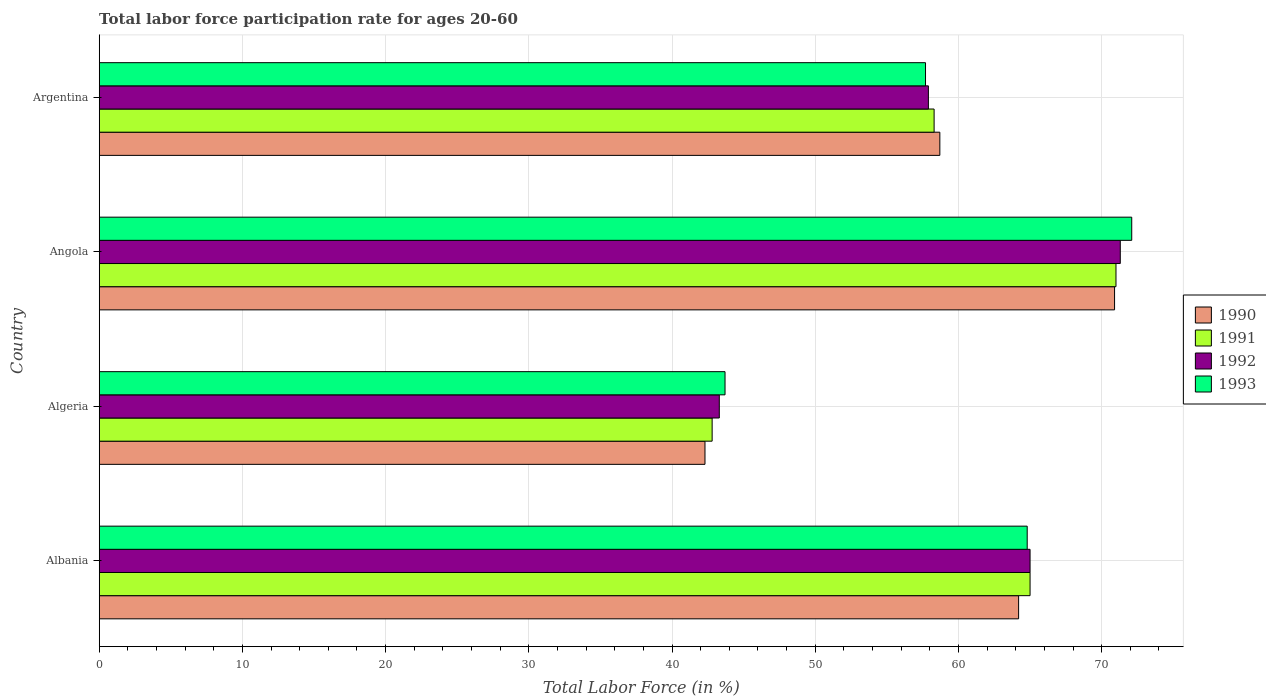How many different coloured bars are there?
Offer a very short reply. 4. How many groups of bars are there?
Keep it short and to the point. 4. How many bars are there on the 4th tick from the top?
Provide a short and direct response. 4. In how many cases, is the number of bars for a given country not equal to the number of legend labels?
Ensure brevity in your answer.  0. What is the labor force participation rate in 1992 in Albania?
Your answer should be very brief. 65. Across all countries, what is the maximum labor force participation rate in 1990?
Make the answer very short. 70.9. Across all countries, what is the minimum labor force participation rate in 1992?
Keep it short and to the point. 43.3. In which country was the labor force participation rate in 1993 maximum?
Offer a very short reply. Angola. In which country was the labor force participation rate in 1992 minimum?
Your response must be concise. Algeria. What is the total labor force participation rate in 1990 in the graph?
Ensure brevity in your answer.  236.1. What is the difference between the labor force participation rate in 1993 in Algeria and that in Angola?
Make the answer very short. -28.4. What is the difference between the labor force participation rate in 1990 in Argentina and the labor force participation rate in 1992 in Algeria?
Give a very brief answer. 15.4. What is the average labor force participation rate in 1991 per country?
Ensure brevity in your answer.  59.27. What is the difference between the labor force participation rate in 1991 and labor force participation rate in 1990 in Albania?
Offer a terse response. 0.8. What is the ratio of the labor force participation rate in 1993 in Algeria to that in Argentina?
Your answer should be compact. 0.76. Is the difference between the labor force participation rate in 1991 in Algeria and Argentina greater than the difference between the labor force participation rate in 1990 in Algeria and Argentina?
Your answer should be compact. Yes. What is the difference between the highest and the second highest labor force participation rate in 1991?
Provide a short and direct response. 6. What is the difference between the highest and the lowest labor force participation rate in 1990?
Keep it short and to the point. 28.6. What does the 3rd bar from the bottom in Algeria represents?
Provide a succinct answer. 1992. Is it the case that in every country, the sum of the labor force participation rate in 1993 and labor force participation rate in 1991 is greater than the labor force participation rate in 1992?
Offer a very short reply. Yes. How many bars are there?
Provide a short and direct response. 16. Are all the bars in the graph horizontal?
Offer a terse response. Yes. What is the difference between two consecutive major ticks on the X-axis?
Your response must be concise. 10. Are the values on the major ticks of X-axis written in scientific E-notation?
Your answer should be compact. No. Does the graph contain any zero values?
Provide a succinct answer. No. Does the graph contain grids?
Your response must be concise. Yes. Where does the legend appear in the graph?
Your answer should be compact. Center right. How many legend labels are there?
Provide a short and direct response. 4. How are the legend labels stacked?
Provide a succinct answer. Vertical. What is the title of the graph?
Give a very brief answer. Total labor force participation rate for ages 20-60. Does "2007" appear as one of the legend labels in the graph?
Provide a succinct answer. No. What is the label or title of the X-axis?
Keep it short and to the point. Total Labor Force (in %). What is the label or title of the Y-axis?
Ensure brevity in your answer.  Country. What is the Total Labor Force (in %) in 1990 in Albania?
Provide a short and direct response. 64.2. What is the Total Labor Force (in %) in 1993 in Albania?
Ensure brevity in your answer.  64.8. What is the Total Labor Force (in %) of 1990 in Algeria?
Offer a very short reply. 42.3. What is the Total Labor Force (in %) in 1991 in Algeria?
Make the answer very short. 42.8. What is the Total Labor Force (in %) in 1992 in Algeria?
Provide a short and direct response. 43.3. What is the Total Labor Force (in %) in 1993 in Algeria?
Your response must be concise. 43.7. What is the Total Labor Force (in %) in 1990 in Angola?
Make the answer very short. 70.9. What is the Total Labor Force (in %) of 1991 in Angola?
Keep it short and to the point. 71. What is the Total Labor Force (in %) in 1992 in Angola?
Offer a very short reply. 71.3. What is the Total Labor Force (in %) of 1993 in Angola?
Your answer should be very brief. 72.1. What is the Total Labor Force (in %) in 1990 in Argentina?
Your answer should be very brief. 58.7. What is the Total Labor Force (in %) of 1991 in Argentina?
Give a very brief answer. 58.3. What is the Total Labor Force (in %) of 1992 in Argentina?
Give a very brief answer. 57.9. What is the Total Labor Force (in %) in 1993 in Argentina?
Give a very brief answer. 57.7. Across all countries, what is the maximum Total Labor Force (in %) of 1990?
Keep it short and to the point. 70.9. Across all countries, what is the maximum Total Labor Force (in %) in 1991?
Ensure brevity in your answer.  71. Across all countries, what is the maximum Total Labor Force (in %) of 1992?
Make the answer very short. 71.3. Across all countries, what is the maximum Total Labor Force (in %) in 1993?
Make the answer very short. 72.1. Across all countries, what is the minimum Total Labor Force (in %) in 1990?
Ensure brevity in your answer.  42.3. Across all countries, what is the minimum Total Labor Force (in %) of 1991?
Your response must be concise. 42.8. Across all countries, what is the minimum Total Labor Force (in %) in 1992?
Ensure brevity in your answer.  43.3. Across all countries, what is the minimum Total Labor Force (in %) of 1993?
Make the answer very short. 43.7. What is the total Total Labor Force (in %) in 1990 in the graph?
Keep it short and to the point. 236.1. What is the total Total Labor Force (in %) in 1991 in the graph?
Provide a succinct answer. 237.1. What is the total Total Labor Force (in %) in 1992 in the graph?
Your answer should be compact. 237.5. What is the total Total Labor Force (in %) of 1993 in the graph?
Keep it short and to the point. 238.3. What is the difference between the Total Labor Force (in %) of 1990 in Albania and that in Algeria?
Provide a short and direct response. 21.9. What is the difference between the Total Labor Force (in %) in 1991 in Albania and that in Algeria?
Your response must be concise. 22.2. What is the difference between the Total Labor Force (in %) of 1992 in Albania and that in Algeria?
Provide a short and direct response. 21.7. What is the difference between the Total Labor Force (in %) in 1993 in Albania and that in Algeria?
Your answer should be very brief. 21.1. What is the difference between the Total Labor Force (in %) in 1992 in Albania and that in Angola?
Provide a short and direct response. -6.3. What is the difference between the Total Labor Force (in %) in 1993 in Albania and that in Angola?
Provide a succinct answer. -7.3. What is the difference between the Total Labor Force (in %) of 1990 in Albania and that in Argentina?
Provide a succinct answer. 5.5. What is the difference between the Total Labor Force (in %) in 1991 in Albania and that in Argentina?
Make the answer very short. 6.7. What is the difference between the Total Labor Force (in %) in 1990 in Algeria and that in Angola?
Make the answer very short. -28.6. What is the difference between the Total Labor Force (in %) in 1991 in Algeria and that in Angola?
Your answer should be very brief. -28.2. What is the difference between the Total Labor Force (in %) in 1992 in Algeria and that in Angola?
Your answer should be compact. -28. What is the difference between the Total Labor Force (in %) of 1993 in Algeria and that in Angola?
Offer a very short reply. -28.4. What is the difference between the Total Labor Force (in %) of 1990 in Algeria and that in Argentina?
Make the answer very short. -16.4. What is the difference between the Total Labor Force (in %) in 1991 in Algeria and that in Argentina?
Make the answer very short. -15.5. What is the difference between the Total Labor Force (in %) of 1992 in Algeria and that in Argentina?
Provide a succinct answer. -14.6. What is the difference between the Total Labor Force (in %) in 1993 in Algeria and that in Argentina?
Provide a short and direct response. -14. What is the difference between the Total Labor Force (in %) in 1992 in Angola and that in Argentina?
Your response must be concise. 13.4. What is the difference between the Total Labor Force (in %) of 1990 in Albania and the Total Labor Force (in %) of 1991 in Algeria?
Your answer should be very brief. 21.4. What is the difference between the Total Labor Force (in %) in 1990 in Albania and the Total Labor Force (in %) in 1992 in Algeria?
Keep it short and to the point. 20.9. What is the difference between the Total Labor Force (in %) of 1991 in Albania and the Total Labor Force (in %) of 1992 in Algeria?
Offer a very short reply. 21.7. What is the difference between the Total Labor Force (in %) in 1991 in Albania and the Total Labor Force (in %) in 1993 in Algeria?
Provide a succinct answer. 21.3. What is the difference between the Total Labor Force (in %) in 1992 in Albania and the Total Labor Force (in %) in 1993 in Algeria?
Offer a terse response. 21.3. What is the difference between the Total Labor Force (in %) of 1990 in Albania and the Total Labor Force (in %) of 1991 in Angola?
Provide a short and direct response. -6.8. What is the difference between the Total Labor Force (in %) of 1990 in Albania and the Total Labor Force (in %) of 1992 in Angola?
Provide a short and direct response. -7.1. What is the difference between the Total Labor Force (in %) in 1991 in Albania and the Total Labor Force (in %) in 1992 in Angola?
Your response must be concise. -6.3. What is the difference between the Total Labor Force (in %) in 1991 in Albania and the Total Labor Force (in %) in 1993 in Angola?
Your answer should be compact. -7.1. What is the difference between the Total Labor Force (in %) of 1992 in Albania and the Total Labor Force (in %) of 1993 in Angola?
Your answer should be compact. -7.1. What is the difference between the Total Labor Force (in %) in 1990 in Albania and the Total Labor Force (in %) in 1993 in Argentina?
Offer a very short reply. 6.5. What is the difference between the Total Labor Force (in %) in 1991 in Albania and the Total Labor Force (in %) in 1992 in Argentina?
Keep it short and to the point. 7.1. What is the difference between the Total Labor Force (in %) of 1992 in Albania and the Total Labor Force (in %) of 1993 in Argentina?
Your answer should be very brief. 7.3. What is the difference between the Total Labor Force (in %) of 1990 in Algeria and the Total Labor Force (in %) of 1991 in Angola?
Provide a succinct answer. -28.7. What is the difference between the Total Labor Force (in %) of 1990 in Algeria and the Total Labor Force (in %) of 1992 in Angola?
Offer a very short reply. -29. What is the difference between the Total Labor Force (in %) of 1990 in Algeria and the Total Labor Force (in %) of 1993 in Angola?
Keep it short and to the point. -29.8. What is the difference between the Total Labor Force (in %) of 1991 in Algeria and the Total Labor Force (in %) of 1992 in Angola?
Your answer should be very brief. -28.5. What is the difference between the Total Labor Force (in %) of 1991 in Algeria and the Total Labor Force (in %) of 1993 in Angola?
Offer a very short reply. -29.3. What is the difference between the Total Labor Force (in %) in 1992 in Algeria and the Total Labor Force (in %) in 1993 in Angola?
Give a very brief answer. -28.8. What is the difference between the Total Labor Force (in %) in 1990 in Algeria and the Total Labor Force (in %) in 1992 in Argentina?
Provide a short and direct response. -15.6. What is the difference between the Total Labor Force (in %) in 1990 in Algeria and the Total Labor Force (in %) in 1993 in Argentina?
Provide a short and direct response. -15.4. What is the difference between the Total Labor Force (in %) of 1991 in Algeria and the Total Labor Force (in %) of 1992 in Argentina?
Provide a short and direct response. -15.1. What is the difference between the Total Labor Force (in %) in 1991 in Algeria and the Total Labor Force (in %) in 1993 in Argentina?
Make the answer very short. -14.9. What is the difference between the Total Labor Force (in %) in 1992 in Algeria and the Total Labor Force (in %) in 1993 in Argentina?
Keep it short and to the point. -14.4. What is the difference between the Total Labor Force (in %) in 1990 in Angola and the Total Labor Force (in %) in 1991 in Argentina?
Offer a terse response. 12.6. What is the difference between the Total Labor Force (in %) in 1990 in Angola and the Total Labor Force (in %) in 1993 in Argentina?
Your response must be concise. 13.2. What is the average Total Labor Force (in %) of 1990 per country?
Provide a succinct answer. 59.02. What is the average Total Labor Force (in %) in 1991 per country?
Offer a terse response. 59.27. What is the average Total Labor Force (in %) in 1992 per country?
Provide a succinct answer. 59.38. What is the average Total Labor Force (in %) of 1993 per country?
Offer a very short reply. 59.58. What is the difference between the Total Labor Force (in %) in 1990 and Total Labor Force (in %) in 1991 in Albania?
Offer a terse response. -0.8. What is the difference between the Total Labor Force (in %) of 1990 and Total Labor Force (in %) of 1993 in Albania?
Provide a succinct answer. -0.6. What is the difference between the Total Labor Force (in %) in 1992 and Total Labor Force (in %) in 1993 in Albania?
Provide a succinct answer. 0.2. What is the difference between the Total Labor Force (in %) in 1990 and Total Labor Force (in %) in 1992 in Algeria?
Your answer should be compact. -1. What is the difference between the Total Labor Force (in %) of 1991 and Total Labor Force (in %) of 1992 in Algeria?
Provide a succinct answer. -0.5. What is the difference between the Total Labor Force (in %) of 1991 and Total Labor Force (in %) of 1993 in Algeria?
Give a very brief answer. -0.9. What is the difference between the Total Labor Force (in %) of 1990 and Total Labor Force (in %) of 1991 in Angola?
Your answer should be very brief. -0.1. What is the difference between the Total Labor Force (in %) of 1990 and Total Labor Force (in %) of 1992 in Angola?
Keep it short and to the point. -0.4. What is the difference between the Total Labor Force (in %) of 1991 and Total Labor Force (in %) of 1992 in Angola?
Your response must be concise. -0.3. What is the difference between the Total Labor Force (in %) in 1991 and Total Labor Force (in %) in 1993 in Angola?
Give a very brief answer. -1.1. What is the difference between the Total Labor Force (in %) in 1992 and Total Labor Force (in %) in 1993 in Angola?
Offer a very short reply. -0.8. What is the difference between the Total Labor Force (in %) of 1990 and Total Labor Force (in %) of 1991 in Argentina?
Provide a short and direct response. 0.4. What is the ratio of the Total Labor Force (in %) of 1990 in Albania to that in Algeria?
Offer a terse response. 1.52. What is the ratio of the Total Labor Force (in %) of 1991 in Albania to that in Algeria?
Provide a succinct answer. 1.52. What is the ratio of the Total Labor Force (in %) in 1992 in Albania to that in Algeria?
Provide a short and direct response. 1.5. What is the ratio of the Total Labor Force (in %) of 1993 in Albania to that in Algeria?
Ensure brevity in your answer.  1.48. What is the ratio of the Total Labor Force (in %) of 1990 in Albania to that in Angola?
Keep it short and to the point. 0.91. What is the ratio of the Total Labor Force (in %) of 1991 in Albania to that in Angola?
Your answer should be compact. 0.92. What is the ratio of the Total Labor Force (in %) in 1992 in Albania to that in Angola?
Keep it short and to the point. 0.91. What is the ratio of the Total Labor Force (in %) of 1993 in Albania to that in Angola?
Make the answer very short. 0.9. What is the ratio of the Total Labor Force (in %) in 1990 in Albania to that in Argentina?
Your answer should be very brief. 1.09. What is the ratio of the Total Labor Force (in %) in 1991 in Albania to that in Argentina?
Your answer should be very brief. 1.11. What is the ratio of the Total Labor Force (in %) of 1992 in Albania to that in Argentina?
Your answer should be compact. 1.12. What is the ratio of the Total Labor Force (in %) of 1993 in Albania to that in Argentina?
Provide a short and direct response. 1.12. What is the ratio of the Total Labor Force (in %) in 1990 in Algeria to that in Angola?
Your answer should be very brief. 0.6. What is the ratio of the Total Labor Force (in %) of 1991 in Algeria to that in Angola?
Offer a terse response. 0.6. What is the ratio of the Total Labor Force (in %) of 1992 in Algeria to that in Angola?
Keep it short and to the point. 0.61. What is the ratio of the Total Labor Force (in %) in 1993 in Algeria to that in Angola?
Give a very brief answer. 0.61. What is the ratio of the Total Labor Force (in %) in 1990 in Algeria to that in Argentina?
Ensure brevity in your answer.  0.72. What is the ratio of the Total Labor Force (in %) of 1991 in Algeria to that in Argentina?
Keep it short and to the point. 0.73. What is the ratio of the Total Labor Force (in %) of 1992 in Algeria to that in Argentina?
Offer a very short reply. 0.75. What is the ratio of the Total Labor Force (in %) of 1993 in Algeria to that in Argentina?
Make the answer very short. 0.76. What is the ratio of the Total Labor Force (in %) in 1990 in Angola to that in Argentina?
Your response must be concise. 1.21. What is the ratio of the Total Labor Force (in %) in 1991 in Angola to that in Argentina?
Offer a terse response. 1.22. What is the ratio of the Total Labor Force (in %) of 1992 in Angola to that in Argentina?
Provide a short and direct response. 1.23. What is the ratio of the Total Labor Force (in %) in 1993 in Angola to that in Argentina?
Your response must be concise. 1.25. What is the difference between the highest and the second highest Total Labor Force (in %) of 1991?
Provide a short and direct response. 6. What is the difference between the highest and the lowest Total Labor Force (in %) in 1990?
Ensure brevity in your answer.  28.6. What is the difference between the highest and the lowest Total Labor Force (in %) of 1991?
Offer a very short reply. 28.2. What is the difference between the highest and the lowest Total Labor Force (in %) of 1992?
Keep it short and to the point. 28. What is the difference between the highest and the lowest Total Labor Force (in %) of 1993?
Provide a succinct answer. 28.4. 